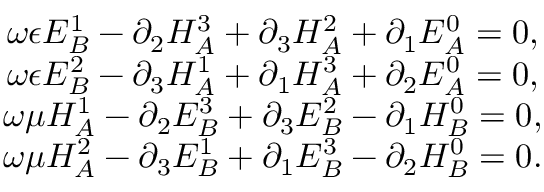<formula> <loc_0><loc_0><loc_500><loc_500>\begin{array} { c } { { \omega \epsilon E _ { B } ^ { 1 } - \partial _ { 2 } H _ { A } ^ { 3 } + \partial _ { 3 } H _ { A } ^ { 2 } + \partial _ { 1 } E _ { A } ^ { 0 } = 0 , } } \\ { { \omega \epsilon E _ { B } ^ { 2 } - \partial _ { 3 } H _ { A } ^ { 1 } + \partial _ { 1 } H _ { A } ^ { 3 } + \partial _ { 2 } E _ { A } ^ { 0 } = 0 , } } \\ { { \omega \mu H _ { A } ^ { 1 } - \partial _ { 2 } E _ { B } ^ { 3 } + \partial _ { 3 } E _ { B } ^ { 2 } - \partial _ { 1 } H _ { B } ^ { 0 } = 0 , } } \\ { { \omega \mu H _ { A } ^ { 2 } - \partial _ { 3 } E _ { B } ^ { 1 } + \partial _ { 1 } E _ { B } ^ { 3 } - \partial _ { 2 } H _ { B } ^ { 0 } = 0 . } } \end{array}</formula> 